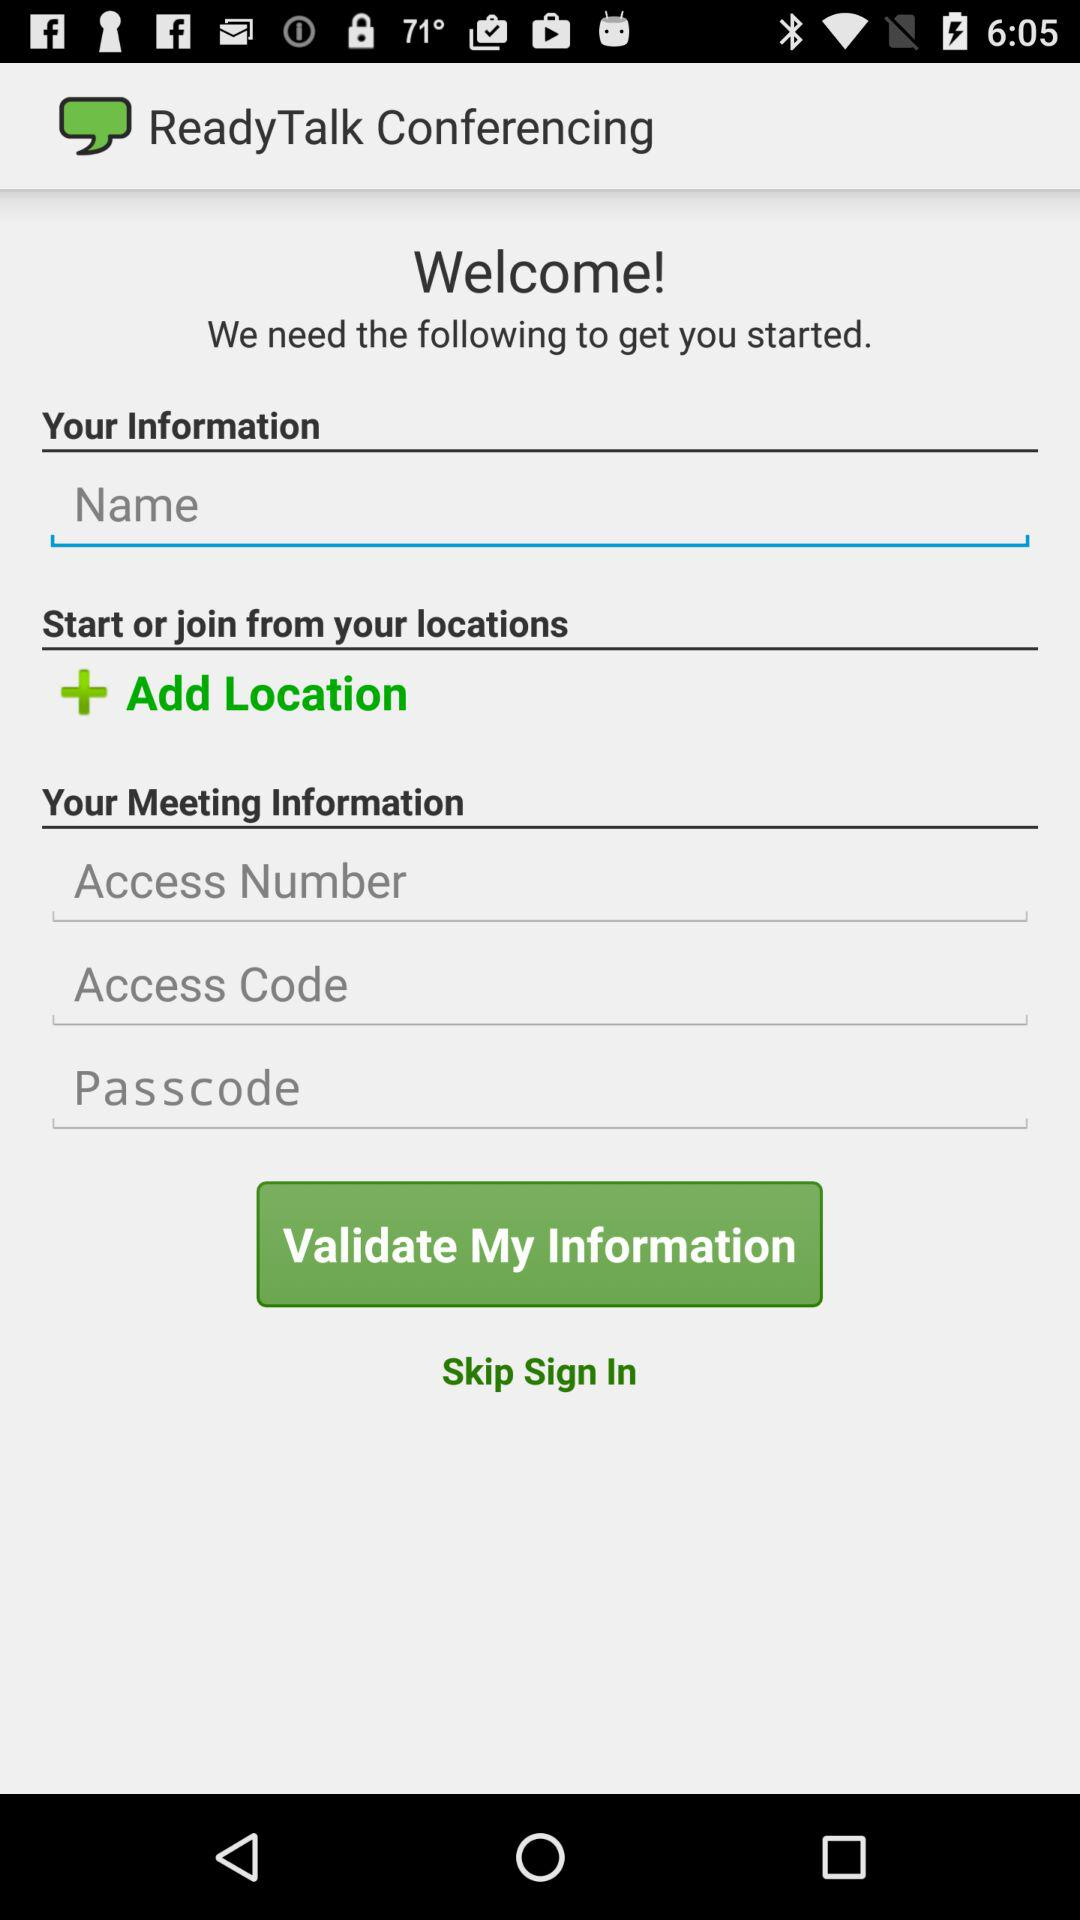How many text inputs are there for meeting information?
Answer the question using a single word or phrase. 3 